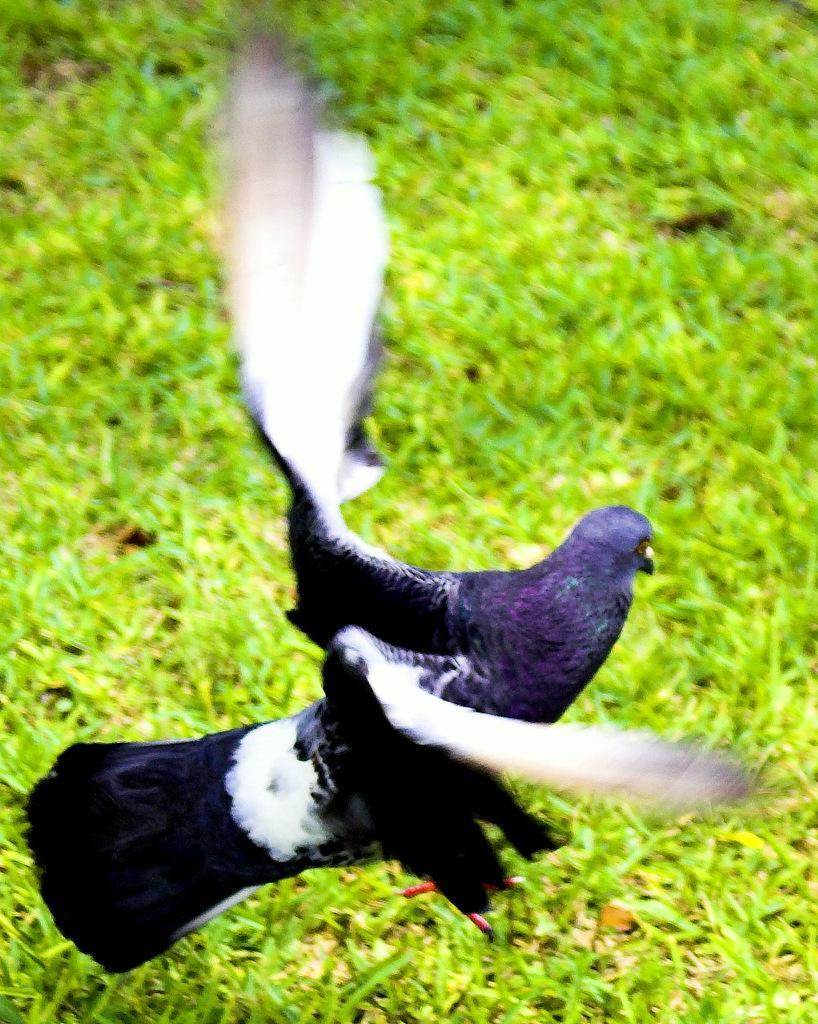How would you summarize this image in a sentence or two? In the picture we can see a grass surface on it we can see a bird standing with its wings open, the bird is blue in color with white color wings and black color tail. 